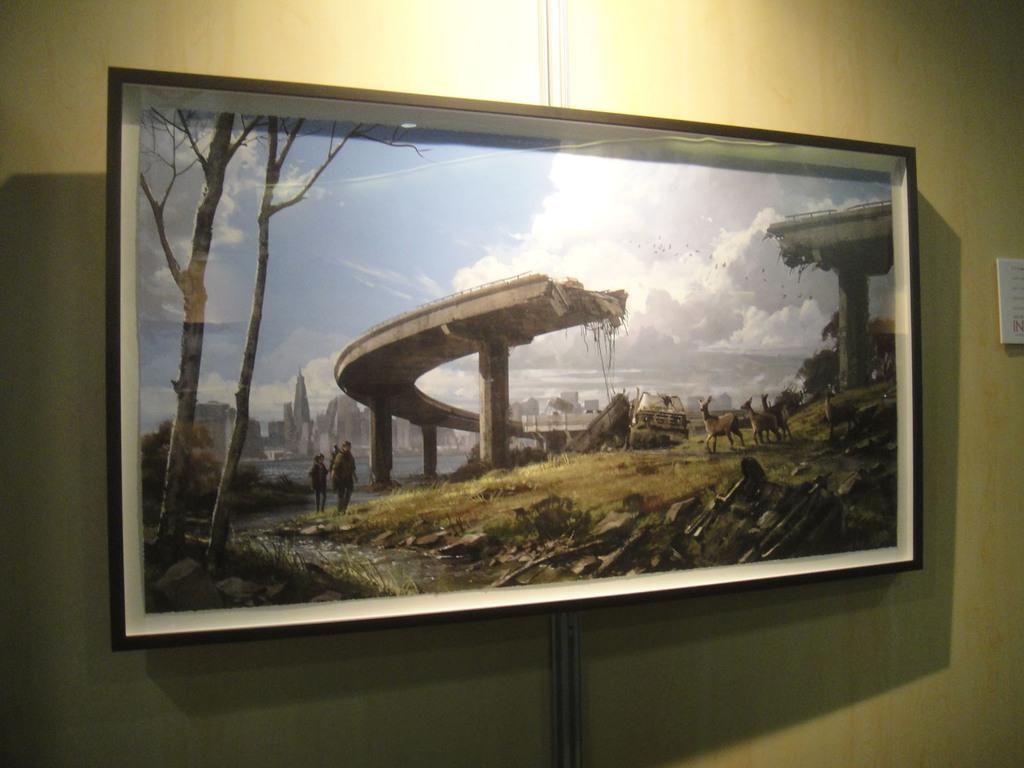Where was the image taken? The image was taken indoors. What can be seen in the background of the image? There is a wall in the background of the image. What is on the wall in the image? There is a picture frame on the wall. How many images are within the picture frame? There are multiple images within the picture frame. What type of box can be seen on the elbow of the person in the image? There is no person or elbow visible in the image, and therefore no box can be seen on an elbow. 